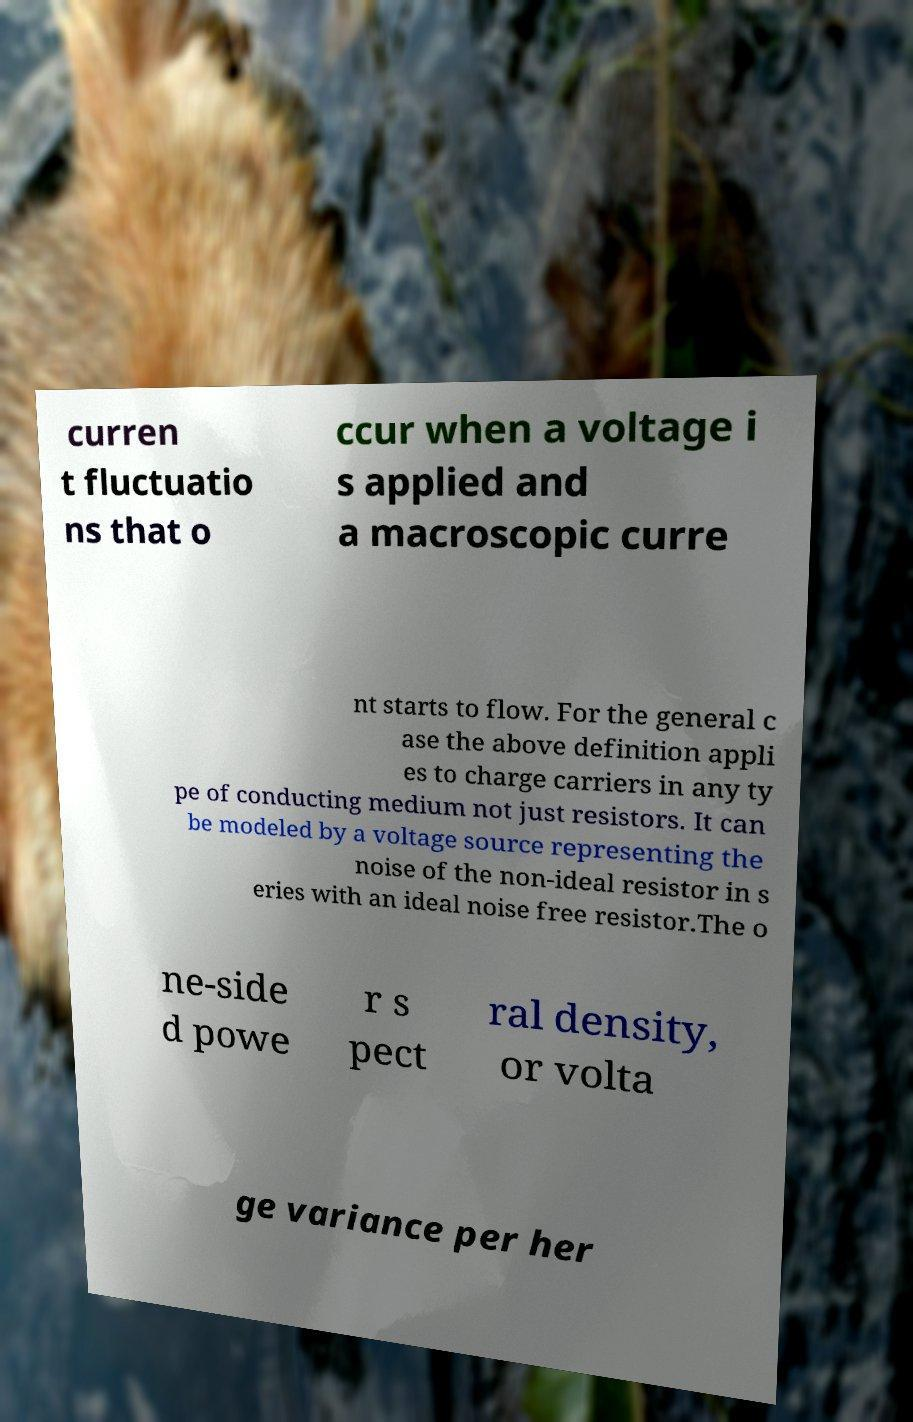Can you read and provide the text displayed in the image?This photo seems to have some interesting text. Can you extract and type it out for me? curren t fluctuatio ns that o ccur when a voltage i s applied and a macroscopic curre nt starts to flow. For the general c ase the above definition appli es to charge carriers in any ty pe of conducting medium not just resistors. It can be modeled by a voltage source representing the noise of the non-ideal resistor in s eries with an ideal noise free resistor.The o ne-side d powe r s pect ral density, or volta ge variance per her 